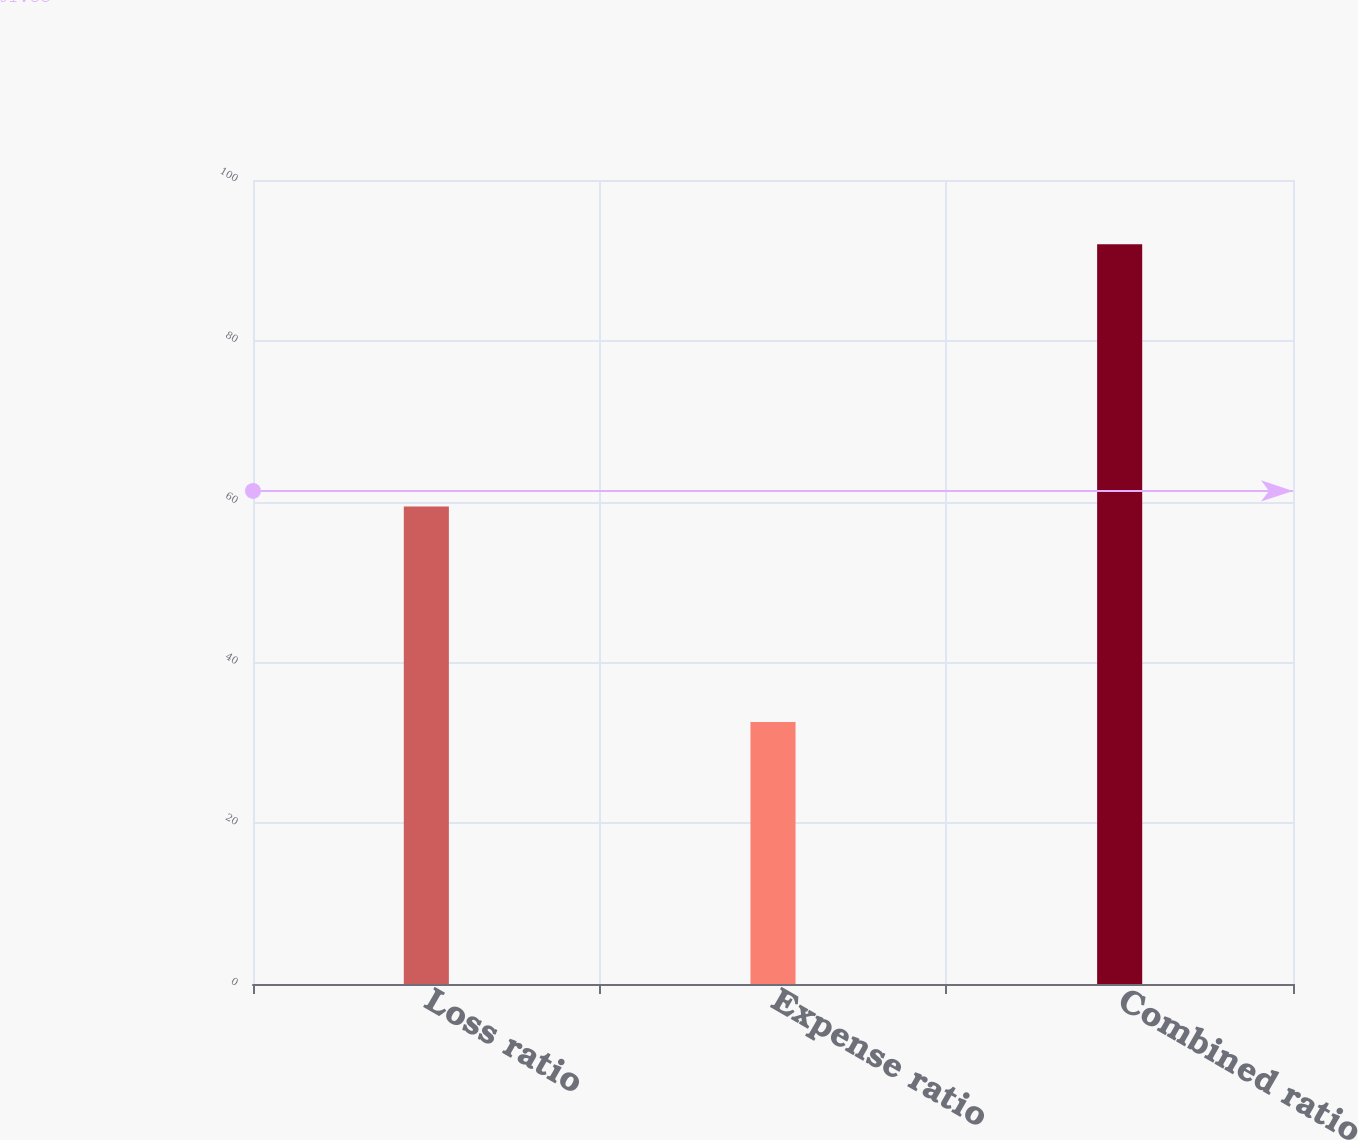Convert chart to OTSL. <chart><loc_0><loc_0><loc_500><loc_500><bar_chart><fcel>Loss ratio<fcel>Expense ratio<fcel>Combined ratio<nl><fcel>59.4<fcel>32.6<fcel>92<nl></chart> 